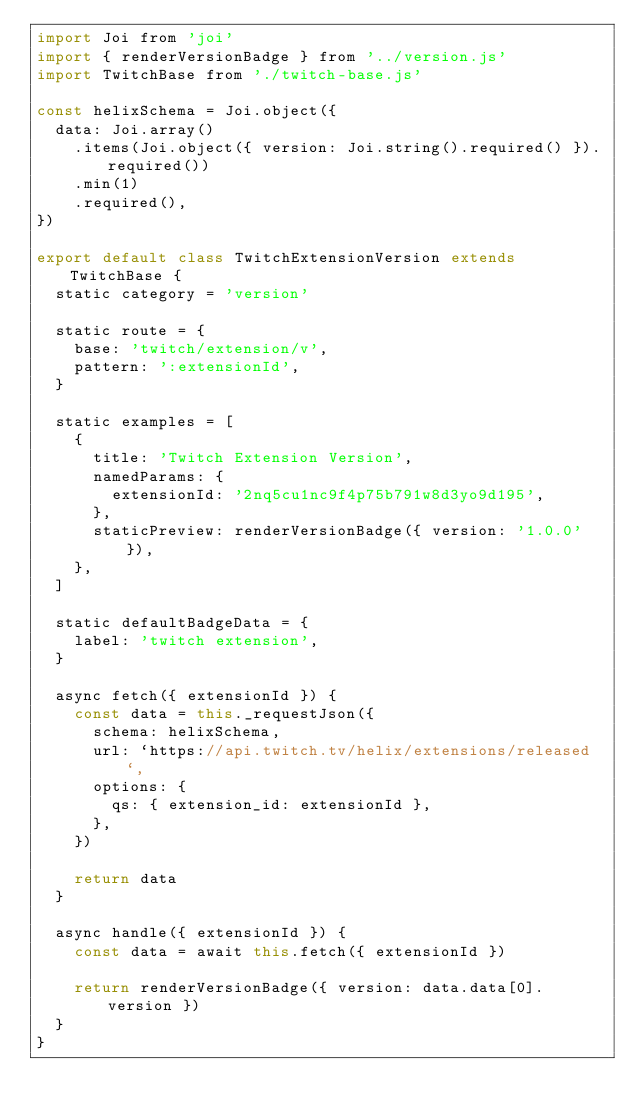Convert code to text. <code><loc_0><loc_0><loc_500><loc_500><_JavaScript_>import Joi from 'joi'
import { renderVersionBadge } from '../version.js'
import TwitchBase from './twitch-base.js'

const helixSchema = Joi.object({
  data: Joi.array()
    .items(Joi.object({ version: Joi.string().required() }).required())
    .min(1)
    .required(),
})

export default class TwitchExtensionVersion extends TwitchBase {
  static category = 'version'

  static route = {
    base: 'twitch/extension/v',
    pattern: ':extensionId',
  }

  static examples = [
    {
      title: 'Twitch Extension Version',
      namedParams: {
        extensionId: '2nq5cu1nc9f4p75b791w8d3yo9d195',
      },
      staticPreview: renderVersionBadge({ version: '1.0.0' }),
    },
  ]

  static defaultBadgeData = {
    label: 'twitch extension',
  }

  async fetch({ extensionId }) {
    const data = this._requestJson({
      schema: helixSchema,
      url: `https://api.twitch.tv/helix/extensions/released`,
      options: {
        qs: { extension_id: extensionId },
      },
    })

    return data
  }

  async handle({ extensionId }) {
    const data = await this.fetch({ extensionId })

    return renderVersionBadge({ version: data.data[0].version })
  }
}
</code> 